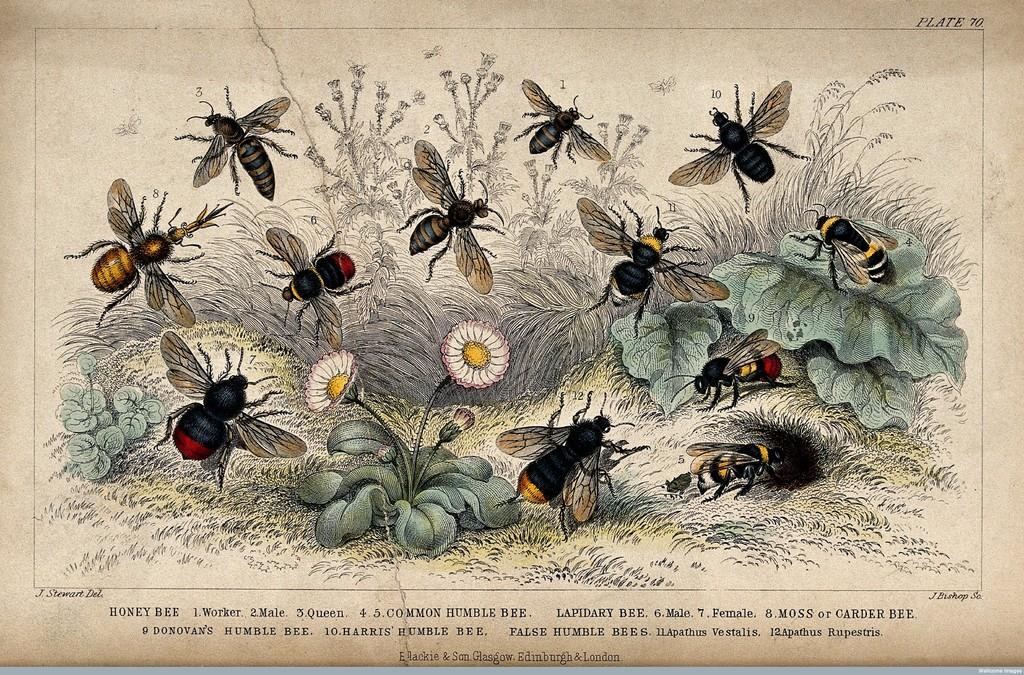Can you describe this image briefly? In this image we can see insects, flowers, plants and some text on the paper. 